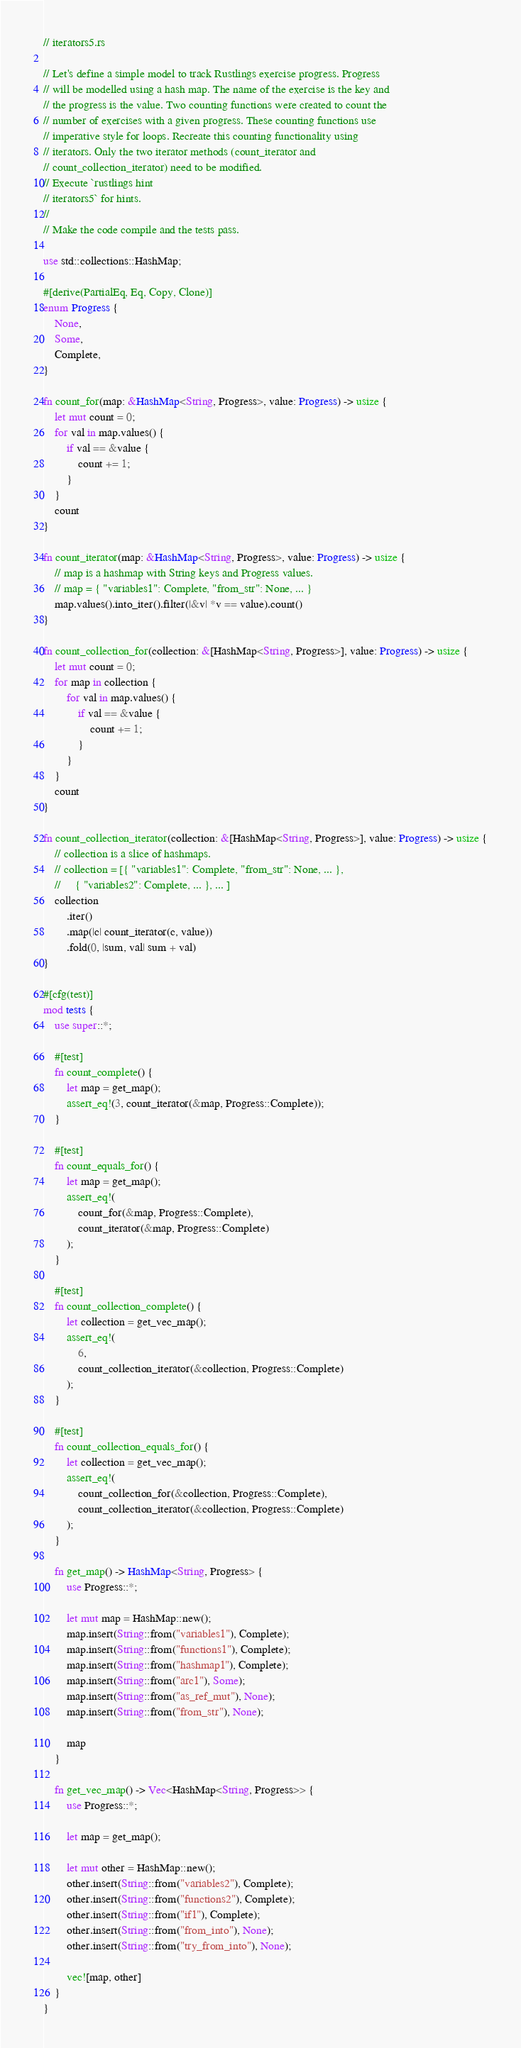Convert code to text. <code><loc_0><loc_0><loc_500><loc_500><_Rust_>// iterators5.rs

// Let's define a simple model to track Rustlings exercise progress. Progress
// will be modelled using a hash map. The name of the exercise is the key and
// the progress is the value. Two counting functions were created to count the
// number of exercises with a given progress. These counting functions use
// imperative style for loops. Recreate this counting functionality using
// iterators. Only the two iterator methods (count_iterator and
// count_collection_iterator) need to be modified.
// Execute `rustlings hint
// iterators5` for hints.
//
// Make the code compile and the tests pass.

use std::collections::HashMap;

#[derive(PartialEq, Eq, Copy, Clone)]
enum Progress {
    None,
    Some,
    Complete,
}

fn count_for(map: &HashMap<String, Progress>, value: Progress) -> usize {
    let mut count = 0;
    for val in map.values() {
        if val == &value {
            count += 1;
        }
    }
    count
}

fn count_iterator(map: &HashMap<String, Progress>, value: Progress) -> usize {
    // map is a hashmap with String keys and Progress values.
    // map = { "variables1": Complete, "from_str": None, ... }
    map.values().into_iter().filter(|&v| *v == value).count()
}

fn count_collection_for(collection: &[HashMap<String, Progress>], value: Progress) -> usize {
    let mut count = 0;
    for map in collection {
        for val in map.values() {
            if val == &value {
                count += 1;
            }
        }
    }
    count
}

fn count_collection_iterator(collection: &[HashMap<String, Progress>], value: Progress) -> usize {
    // collection is a slice of hashmaps.
    // collection = [{ "variables1": Complete, "from_str": None, ... },
    //     { "variables2": Complete, ... }, ... ]
    collection
        .iter()
        .map(|c| count_iterator(c, value))
        .fold(0, |sum, val| sum + val)
}

#[cfg(test)]
mod tests {
    use super::*;

    #[test]
    fn count_complete() {
        let map = get_map();
        assert_eq!(3, count_iterator(&map, Progress::Complete));
    }

    #[test]
    fn count_equals_for() {
        let map = get_map();
        assert_eq!(
            count_for(&map, Progress::Complete),
            count_iterator(&map, Progress::Complete)
        );
    }

    #[test]
    fn count_collection_complete() {
        let collection = get_vec_map();
        assert_eq!(
            6,
            count_collection_iterator(&collection, Progress::Complete)
        );
    }

    #[test]
    fn count_collection_equals_for() {
        let collection = get_vec_map();
        assert_eq!(
            count_collection_for(&collection, Progress::Complete),
            count_collection_iterator(&collection, Progress::Complete)
        );
    }

    fn get_map() -> HashMap<String, Progress> {
        use Progress::*;

        let mut map = HashMap::new();
        map.insert(String::from("variables1"), Complete);
        map.insert(String::from("functions1"), Complete);
        map.insert(String::from("hashmap1"), Complete);
        map.insert(String::from("arc1"), Some);
        map.insert(String::from("as_ref_mut"), None);
        map.insert(String::from("from_str"), None);

        map
    }

    fn get_vec_map() -> Vec<HashMap<String, Progress>> {
        use Progress::*;

        let map = get_map();

        let mut other = HashMap::new();
        other.insert(String::from("variables2"), Complete);
        other.insert(String::from("functions2"), Complete);
        other.insert(String::from("if1"), Complete);
        other.insert(String::from("from_into"), None);
        other.insert(String::from("try_from_into"), None);

        vec![map, other]
    }
}
</code> 